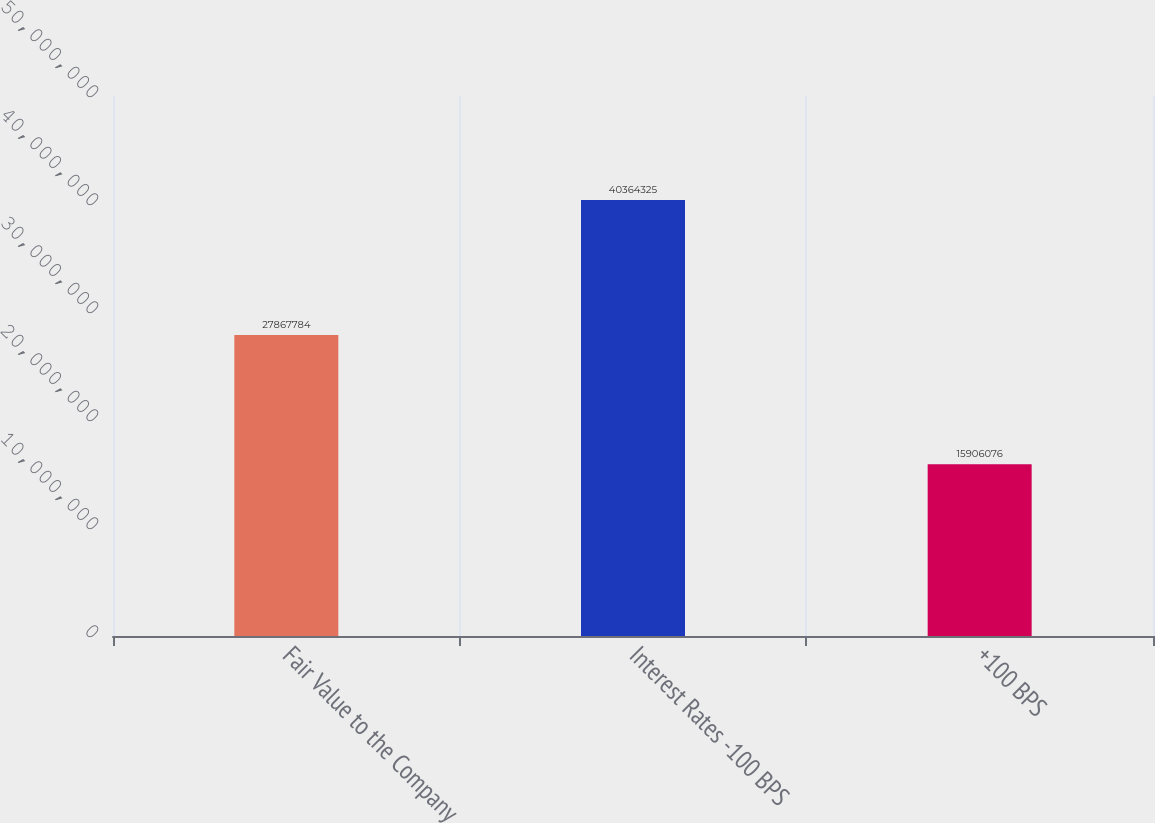<chart> <loc_0><loc_0><loc_500><loc_500><bar_chart><fcel>Fair Value to the Company<fcel>Interest Rates -100 BPS<fcel>+100 BPS<nl><fcel>2.78678e+07<fcel>4.03643e+07<fcel>1.59061e+07<nl></chart> 